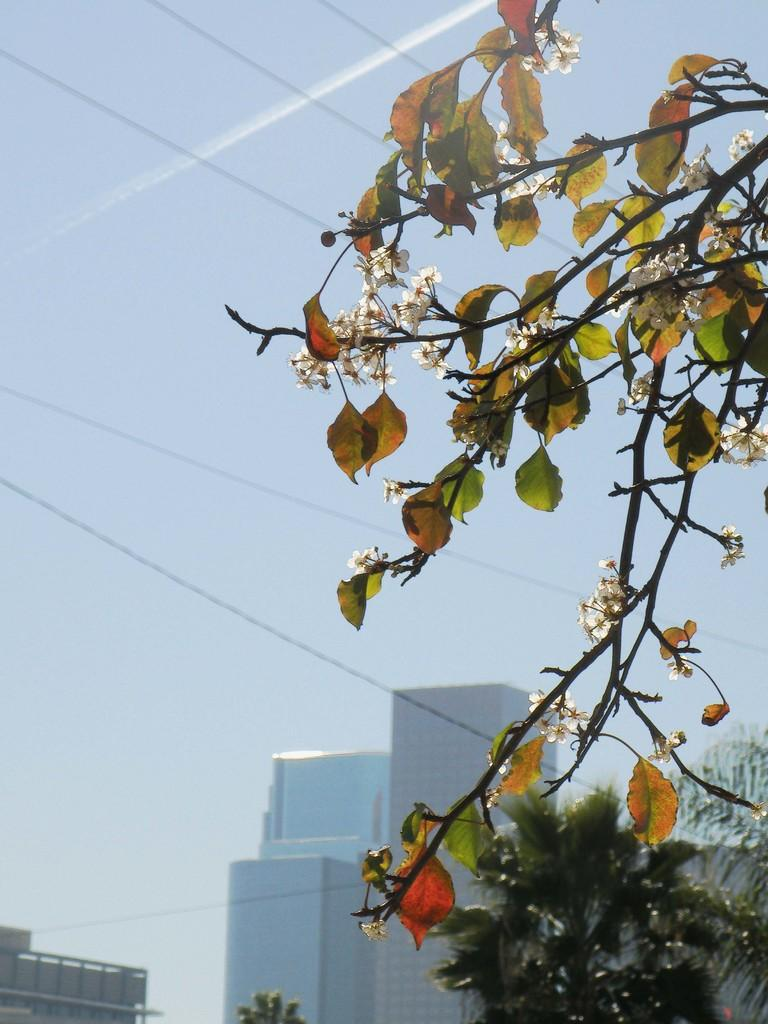What type of plants can be seen in the image? There is a group of flowers in the image. What else can be seen on the branches in the image? There are leaves on the branches in the image. What is visible in the background of the image? There is a group of trees and buildings visible in the background of the image. What part of the natural environment is visible in the image? The sky is visible in the background of the image. What level of pleasure can be observed on the moon in the image? There is no moon present in the image, and therefore no level of pleasure can be observed. 